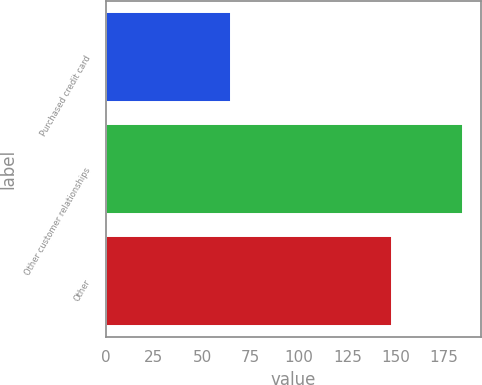<chart> <loc_0><loc_0><loc_500><loc_500><bar_chart><fcel>Purchased credit card<fcel>Other customer relationships<fcel>Other<nl><fcel>65<fcel>185<fcel>148<nl></chart> 